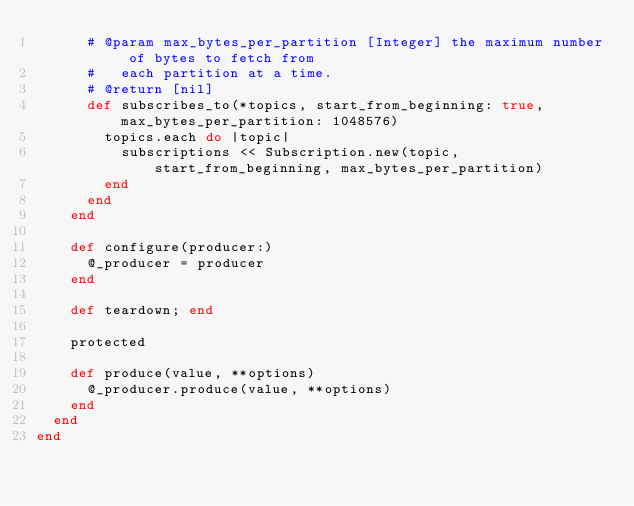<code> <loc_0><loc_0><loc_500><loc_500><_Ruby_>      # @param max_bytes_per_partition [Integer] the maximum number of bytes to fetch from
      #   each partition at a time.
      # @return [nil]
      def subscribes_to(*topics, start_from_beginning: true, max_bytes_per_partition: 1048576)
        topics.each do |topic|
          subscriptions << Subscription.new(topic, start_from_beginning, max_bytes_per_partition)
        end
      end
    end

    def configure(producer:)
      @_producer = producer
    end

    def teardown; end

    protected

    def produce(value, **options)
      @_producer.produce(value, **options)
    end
  end
end
</code> 